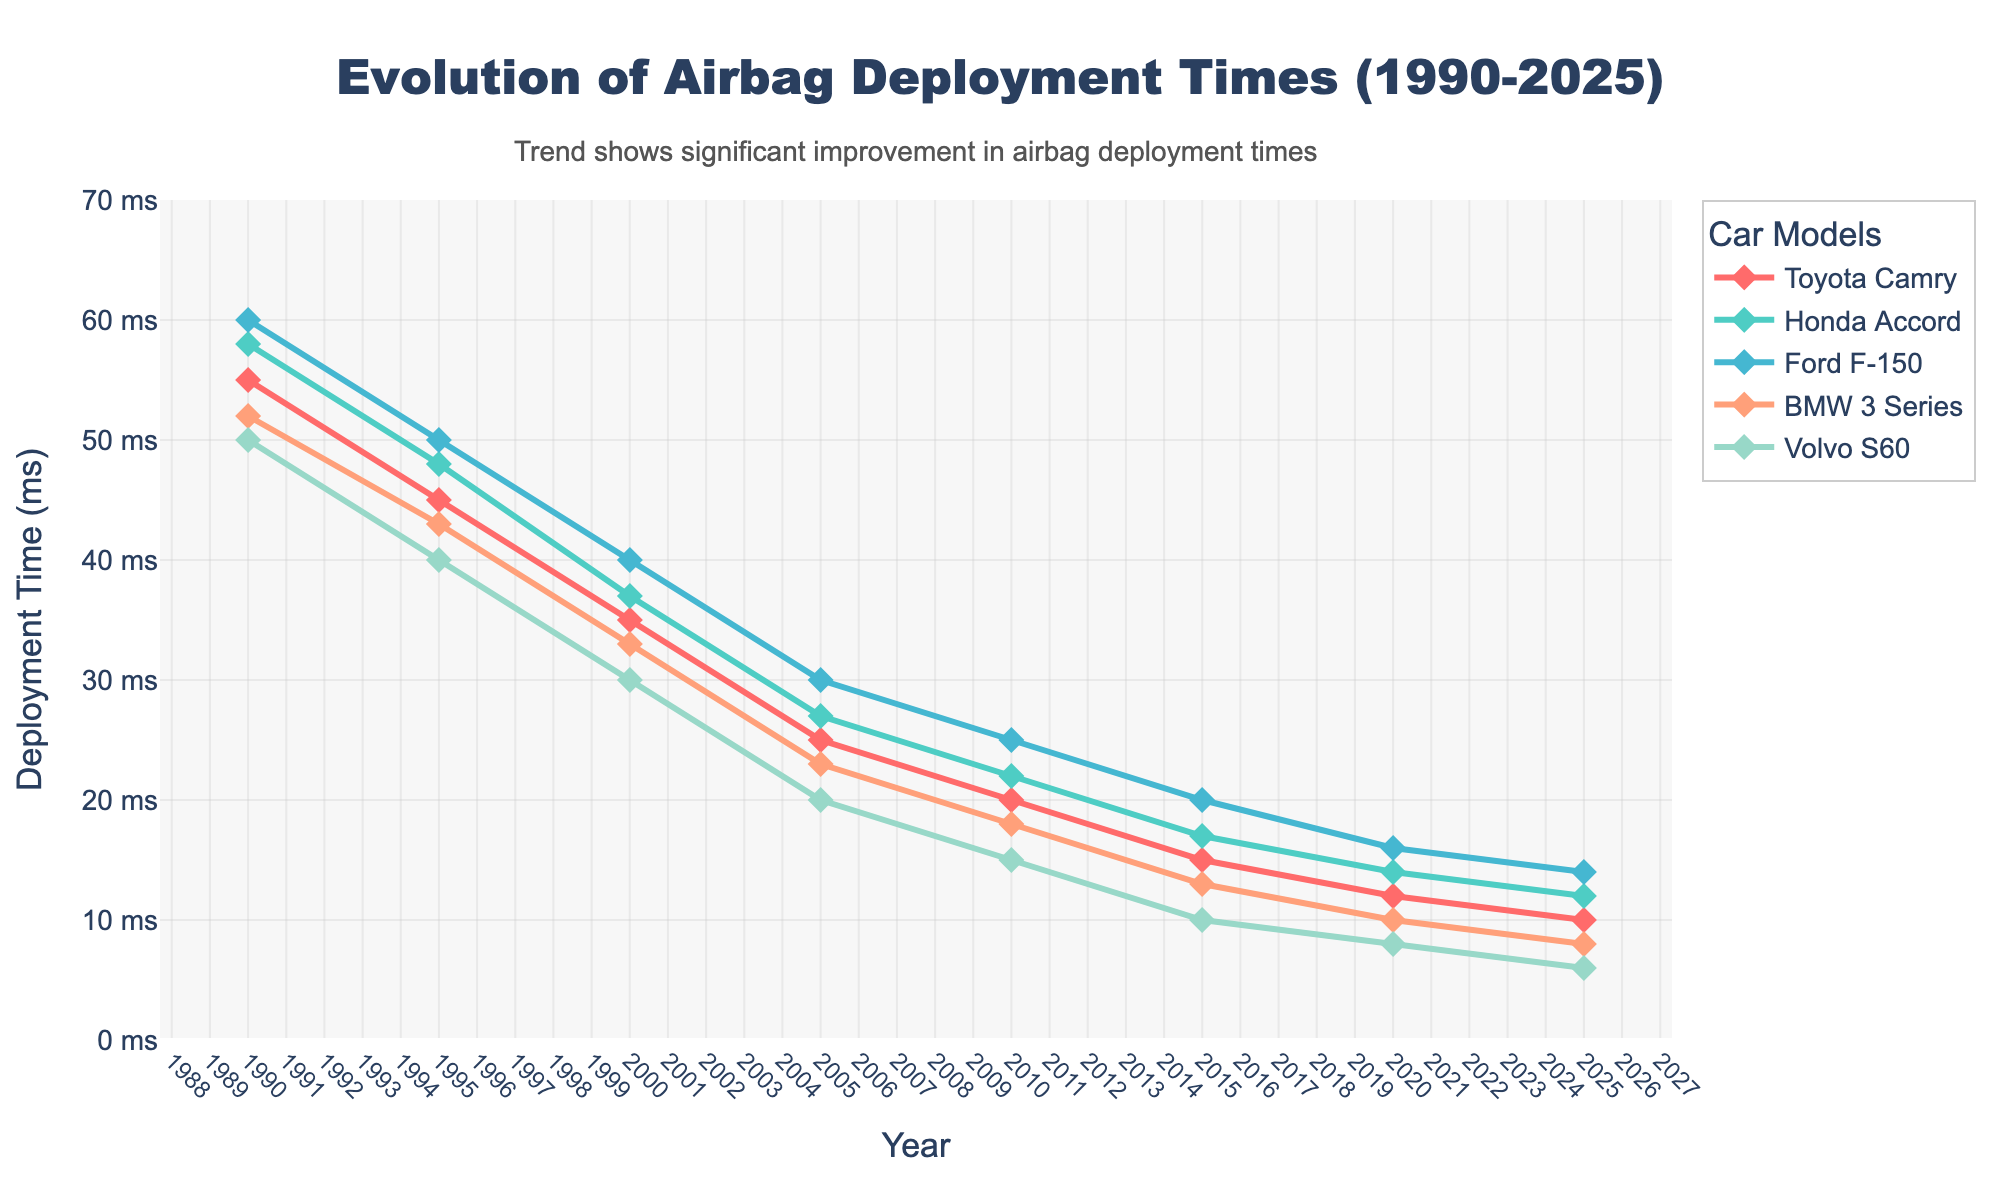What's the current (2025) airbag deployment time for the Volvo S60? To find the airbag deployment time for the Volvo S60 in 2025, we look at the last data point in the series for the Volvo S60. The deployment time provided is 6 milliseconds (ms).
Answer: 6 ms Which car model had the greatest decrease in airbag deployment time from 1990 to 2025? We need to calculate the difference between the deployment times for each car model in 1990 and 2025. For Toyota Camry: 55 - 10 = 45 ms, Honda Accord: 58 - 12 = 46 ms, Ford F-150: 60 - 14 = 46 ms, BMW 3 Series: 52 - 8 = 44 ms, Volvo S60: 50 - 6 = 44 ms. The Honda Accord and Ford F-150 have the greatest decrease of 46 ms.
Answer: Honda Accord and Ford F-150 Which year did the BMW 3 Series first achieve a deployment time less than 30 ms? We trace the BMW 3 Series' data points and find the first year where the deployment time dropped below 30 ms, which happens in 2005 with a deployment time of 23 ms.
Answer: 2005 What is the average deployment time across all car models in 2020? Add the deployment times for all car models in 2020 and divide by the number of models: (12 + 14 + 16 + 10 + 8) / 5 = 60 / 5 = 12 ms.
Answer: 12 ms What's the visual trend observed in airbag deployment times from 1990 to 2025? Observing the lines on the chart, all car models show a decreasing trend in deployment times from 1990 to 2025, indicating improvements over time.
Answer: Decreasing Which car model shows the steepest decline in deployment time between 1990 and 2000? To determine the steepest decline, we calculate the decline for each model between 1990 and 2000. Toyota Camry: 55 - 35 = 20 ms, Honda Accord: 58 - 37 = 21 ms, Ford F-150: 60 - 40 = 20 ms, BMW 3 Series: 52 - 33 = 19 ms, Volvo S60: 50 - 30 = 20 ms. The Honda Accord shows the steepest decline of 21 ms.
Answer: Honda Accord In which year did the Honda Accord achieve a deployment time of approximately 22 ms? According to the chart, the Honda Accord shows a deployment time of around 22 ms in 2010.
Answer: 2010 By how many milliseconds did the Ford F-150's airbag deployment time reduce between 2015 and 2025? The airbag deployment time for the Ford F-150 in 2015 is 20 ms and in 2025 is 14 ms. The reduction is 20 - 14 = 6 ms.
Answer: 6 ms Which car model consistently had the lowest deployment time in the 1990s? From the data, we see the Volvo S60 had the lowest airbag deployment times throughout the 1990s, with values: 50 ms in 1990 and 40 ms in 1995.
Answer: Volvo S60 